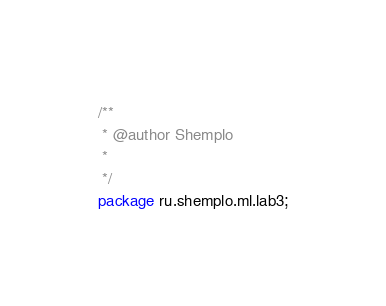Convert code to text. <code><loc_0><loc_0><loc_500><loc_500><_Java_>/**
 * @author Shemplo
 *
 */
package ru.shemplo.ml.lab3;
</code> 